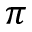<formula> <loc_0><loc_0><loc_500><loc_500>\pi</formula> 